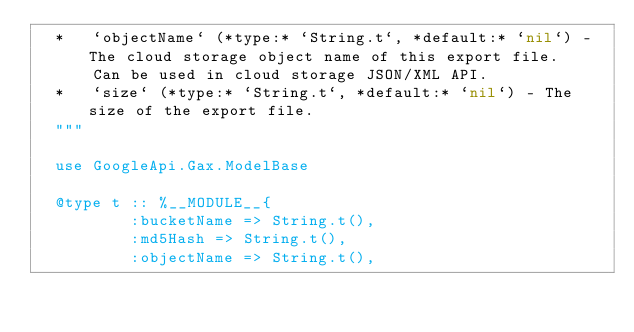<code> <loc_0><loc_0><loc_500><loc_500><_Elixir_>  *   `objectName` (*type:* `String.t`, *default:* `nil`) - The cloud storage object name of this export file.
      Can be used in cloud storage JSON/XML API.
  *   `size` (*type:* `String.t`, *default:* `nil`) - The size of the export file.
  """

  use GoogleApi.Gax.ModelBase

  @type t :: %__MODULE__{
          :bucketName => String.t(),
          :md5Hash => String.t(),
          :objectName => String.t(),</code> 